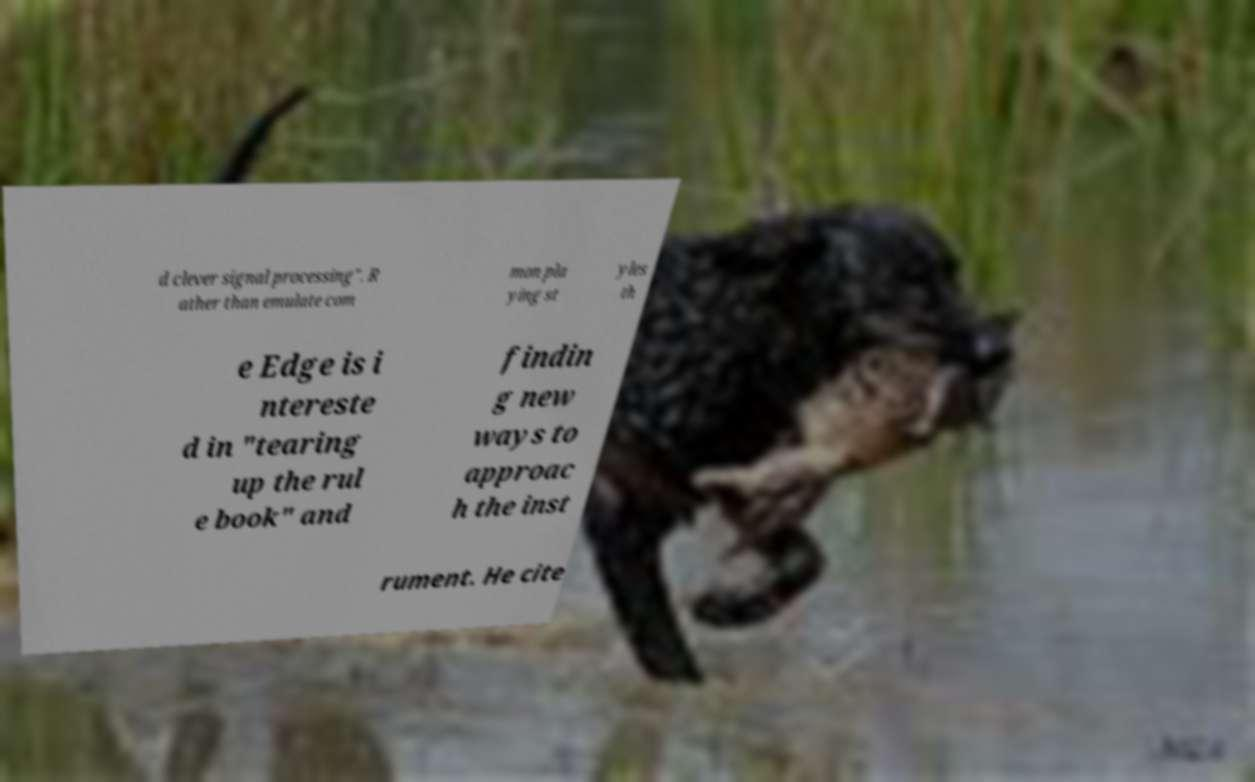Please identify and transcribe the text found in this image. d clever signal processing". R ather than emulate com mon pla ying st yles th e Edge is i ntereste d in "tearing up the rul e book" and findin g new ways to approac h the inst rument. He cite 